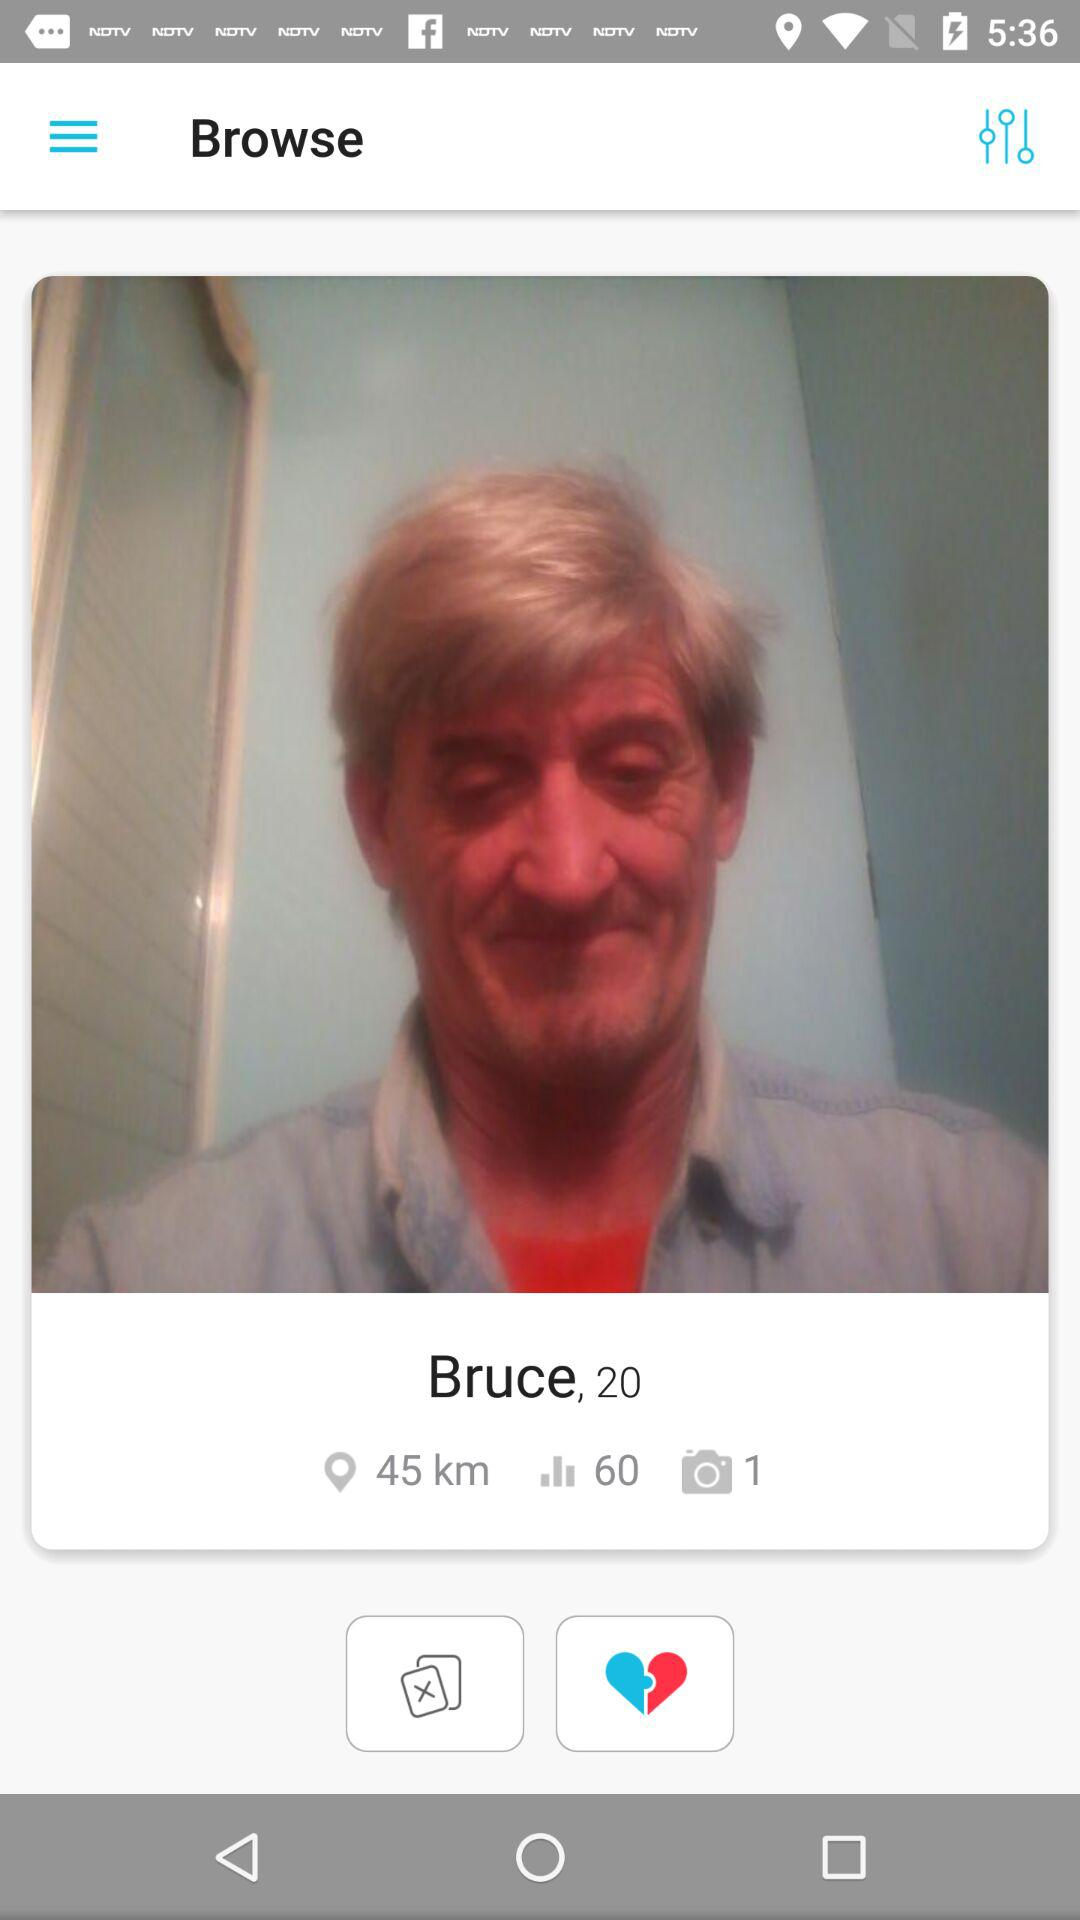How many photos are there? There is 1 photo. 